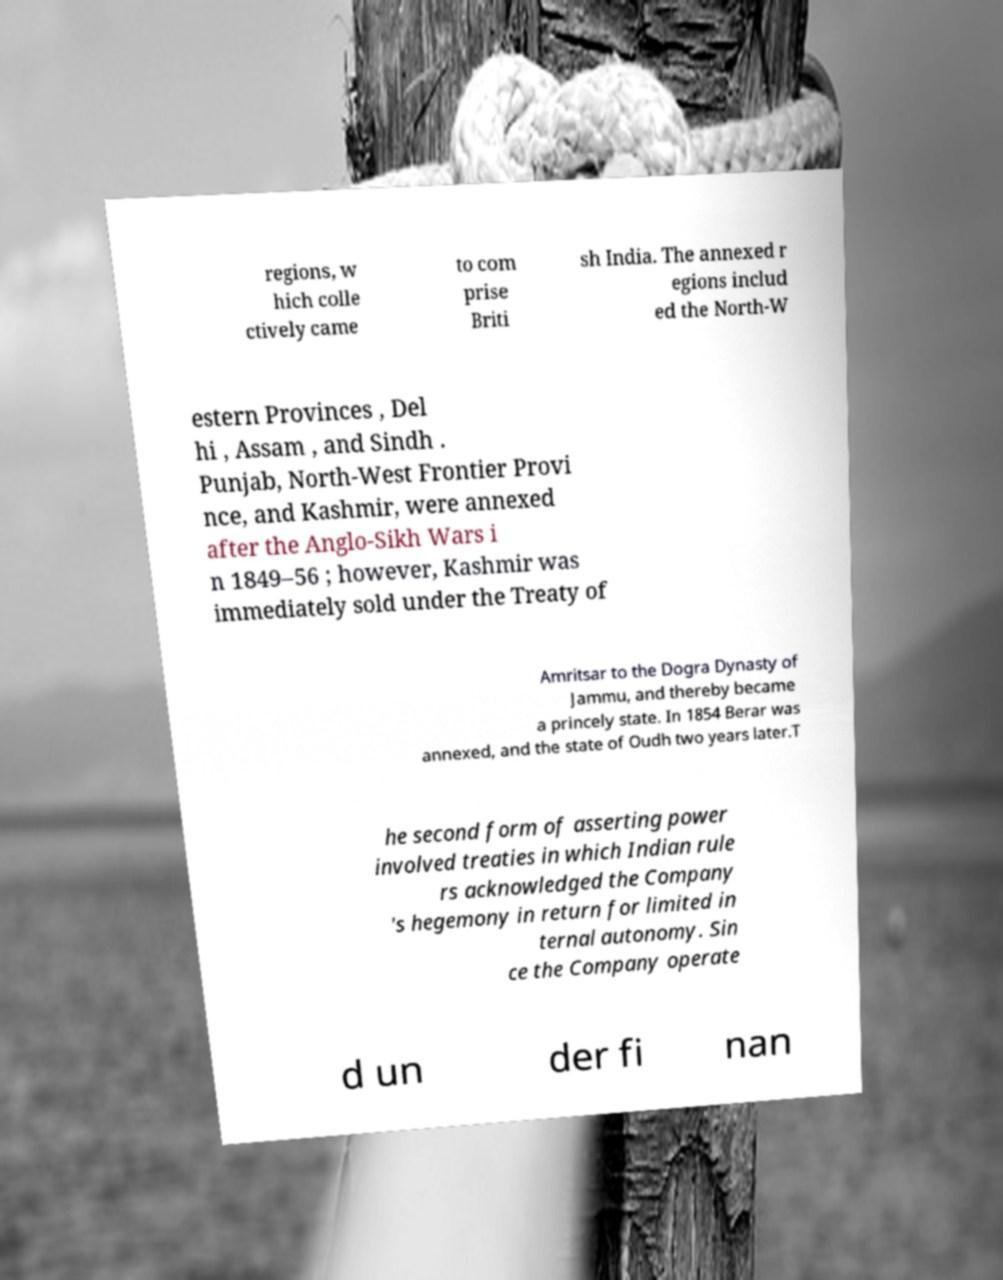Can you read and provide the text displayed in the image?This photo seems to have some interesting text. Can you extract and type it out for me? regions, w hich colle ctively came to com prise Briti sh India. The annexed r egions includ ed the North-W estern Provinces , Del hi , Assam , and Sindh . Punjab, North-West Frontier Provi nce, and Kashmir, were annexed after the Anglo-Sikh Wars i n 1849–56 ; however, Kashmir was immediately sold under the Treaty of Amritsar to the Dogra Dynasty of Jammu, and thereby became a princely state. In 1854 Berar was annexed, and the state of Oudh two years later.T he second form of asserting power involved treaties in which Indian rule rs acknowledged the Company 's hegemony in return for limited in ternal autonomy. Sin ce the Company operate d un der fi nan 